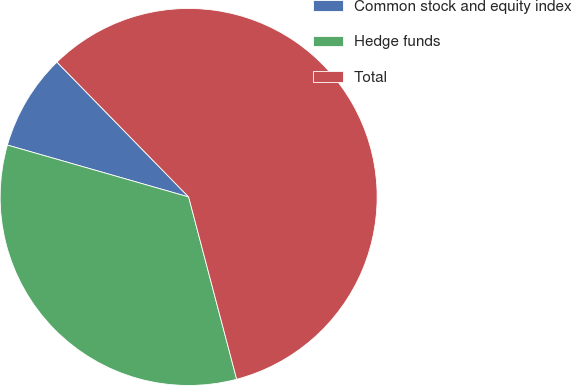Convert chart to OTSL. <chart><loc_0><loc_0><loc_500><loc_500><pie_chart><fcel>Common stock and equity index<fcel>Hedge funds<fcel>Total<nl><fcel>8.25%<fcel>33.54%<fcel>58.21%<nl></chart> 